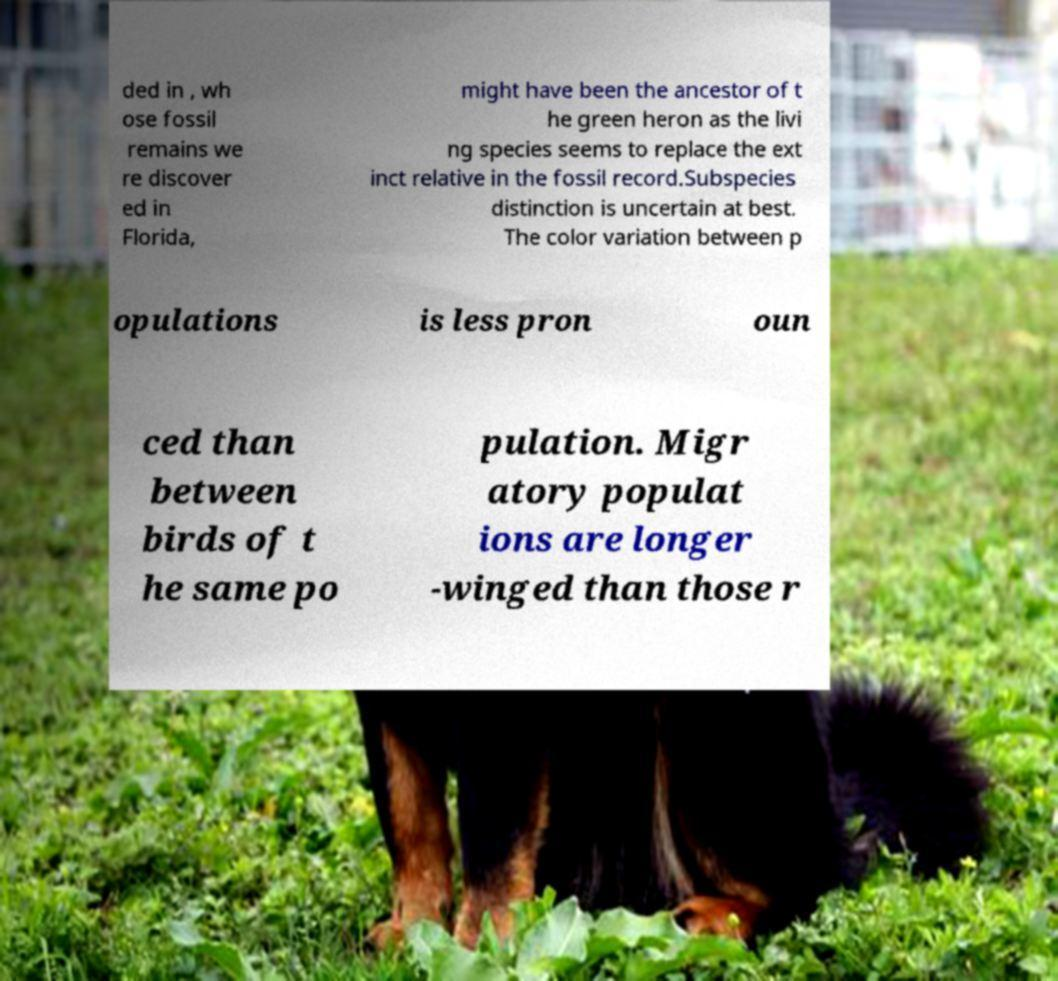There's text embedded in this image that I need extracted. Can you transcribe it verbatim? ded in , wh ose fossil remains we re discover ed in Florida, might have been the ancestor of t he green heron as the livi ng species seems to replace the ext inct relative in the fossil record.Subspecies distinction is uncertain at best. The color variation between p opulations is less pron oun ced than between birds of t he same po pulation. Migr atory populat ions are longer -winged than those r 